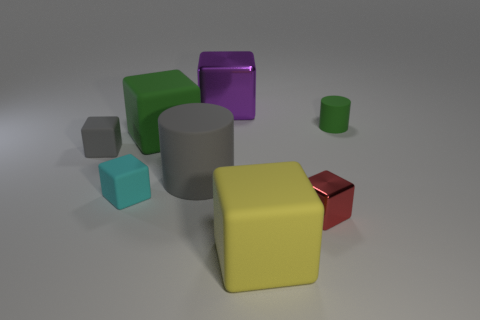What color is the large metal thing?
Provide a succinct answer. Purple. What number of objects are tiny purple metal cylinders or shiny blocks?
Provide a short and direct response. 2. What is the shape of the small rubber object that is to the right of the block behind the tiny matte cylinder?
Offer a terse response. Cylinder. What number of other things are there of the same material as the large green cube
Keep it short and to the point. 5. Does the yellow block have the same material as the tiny block to the right of the large purple object?
Provide a short and direct response. No. What number of objects are either big rubber blocks behind the tiny cyan rubber cube or things behind the gray matte cylinder?
Your answer should be very brief. 4. How many other objects are the same color as the big metallic thing?
Ensure brevity in your answer.  0. Are there more large objects that are in front of the purple metallic object than green matte objects that are to the left of the tiny gray block?
Provide a short and direct response. Yes. Is there anything else that is the same size as the red metal object?
Your answer should be compact. Yes. What number of cubes are small blue rubber things or small red metal objects?
Your answer should be very brief. 1. 